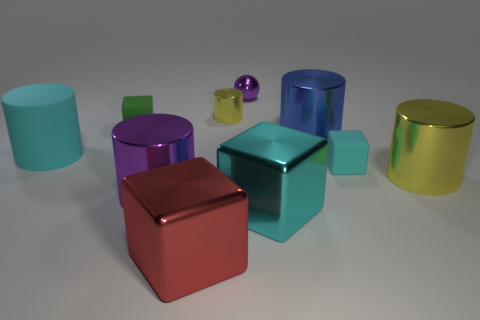Is the shape of the tiny cyan thing the same as the big cyan thing on the right side of the purple metallic sphere?
Offer a very short reply. Yes. Are there the same number of large purple objects and big yellow metallic balls?
Offer a terse response. No. Are there the same number of tiny cubes that are behind the small purple thing and small purple shiny balls in front of the big cyan matte cylinder?
Offer a terse response. Yes. How many other things are made of the same material as the red object?
Give a very brief answer. 6. What number of rubber objects are red cubes or big purple balls?
Make the answer very short. 0. Is the shape of the purple thing in front of the ball the same as  the blue shiny object?
Keep it short and to the point. Yes. Are there more purple balls on the left side of the tiny cyan block than large green matte balls?
Your answer should be very brief. Yes. How many blocks are both on the left side of the big blue object and behind the red metallic thing?
Make the answer very short. 2. The small rubber thing that is right of the green object that is to the left of the tiny metallic sphere is what color?
Offer a terse response. Cyan. What number of spheres have the same color as the small cylinder?
Keep it short and to the point. 0. 